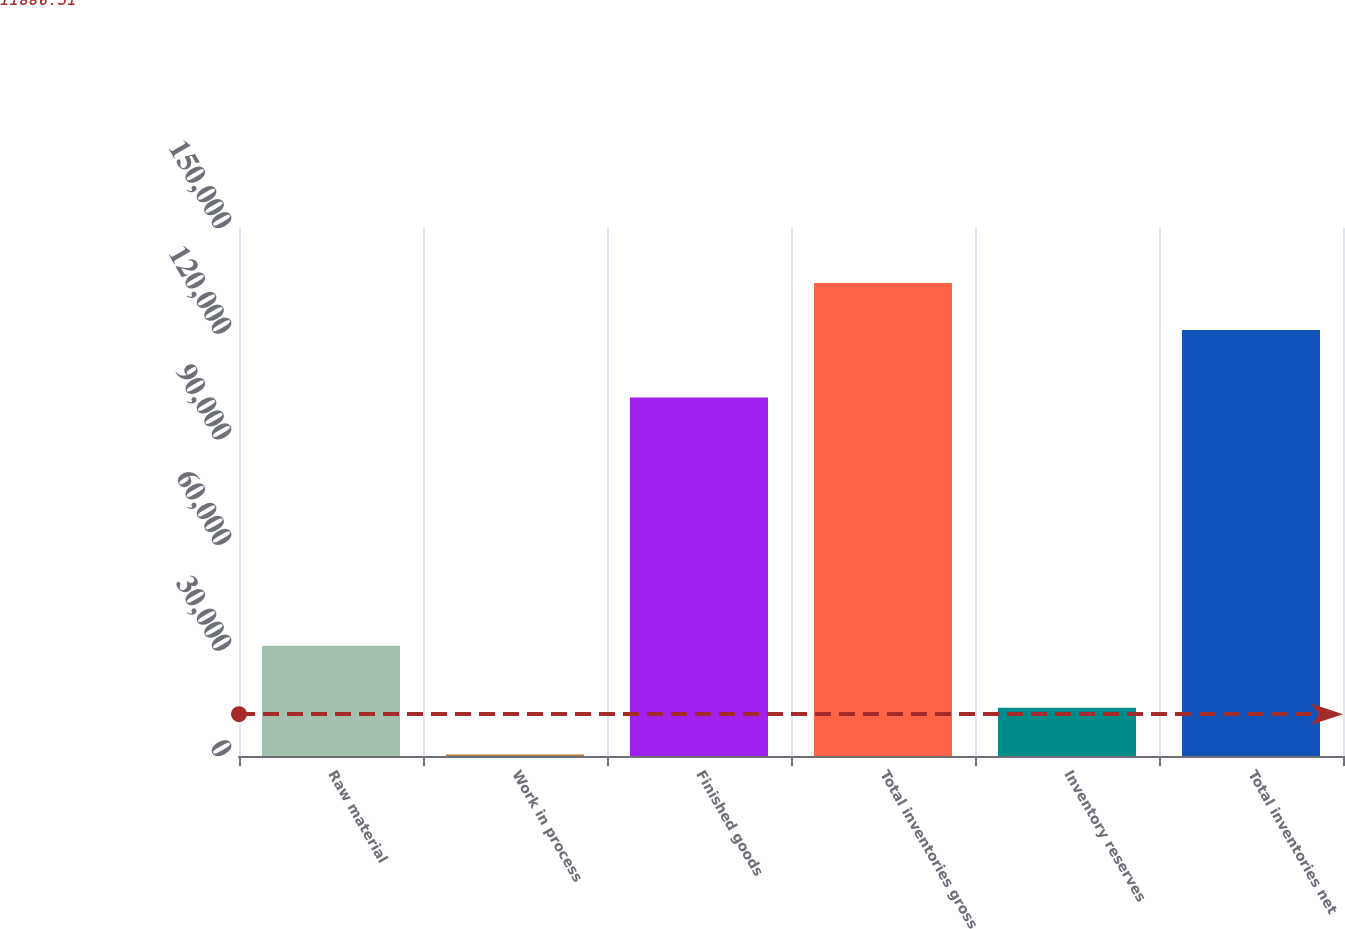<chart> <loc_0><loc_0><loc_500><loc_500><bar_chart><fcel>Raw material<fcel>Work in process<fcel>Finished goods<fcel>Total inventories gross<fcel>Inventory reserves<fcel>Total inventories net<nl><fcel>31335<fcel>415<fcel>101834<fcel>134340<fcel>13731.9<fcel>121023<nl></chart> 